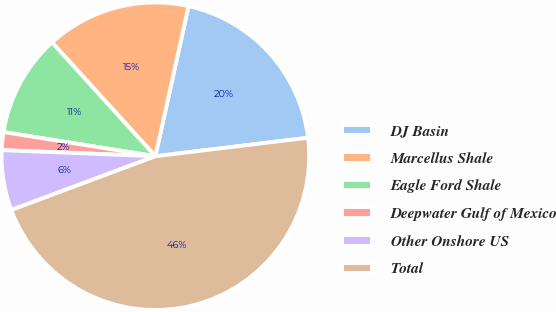<chart> <loc_0><loc_0><loc_500><loc_500><pie_chart><fcel>DJ Basin<fcel>Marcellus Shale<fcel>Eagle Ford Shale<fcel>Deepwater Gulf of Mexico<fcel>Other Onshore US<fcel>Total<nl><fcel>19.62%<fcel>15.19%<fcel>10.75%<fcel>1.88%<fcel>6.32%<fcel>46.23%<nl></chart> 